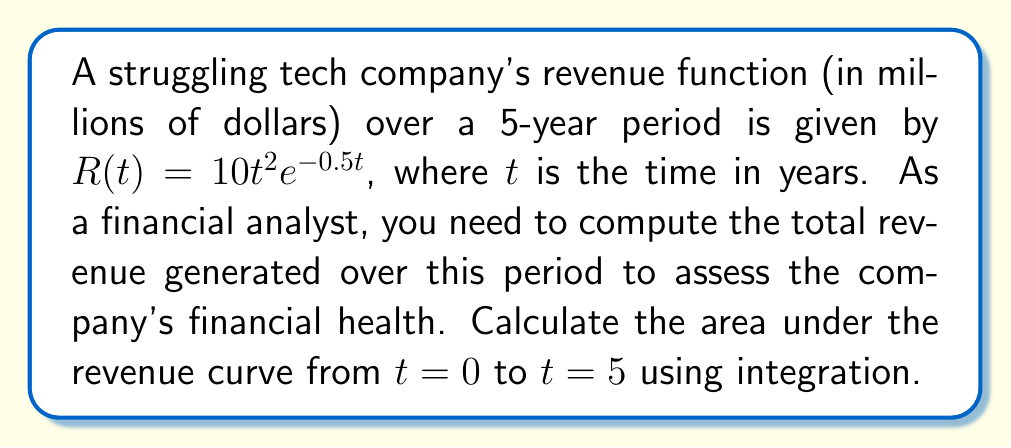Teach me how to tackle this problem. To solve this problem, we need to integrate the revenue function $R(t)$ from $t=0$ to $t=5$. Let's break it down step-by-step:

1) The revenue function is $R(t) = 10t^2e^{-0.5t}$

2) We need to calculate $\int_0^5 R(t) dt$

3) Set up the integral:
   $$\int_0^5 10t^2e^{-0.5t} dt$$

4) This integral cannot be solved using basic integration techniques. We need to use integration by parts twice.

5) Let $u = t^2$ and $dv = e^{-0.5t}dt$
   Then $du = 2t dt$ and $v = -2e^{-0.5t}$

6) Apply integration by parts: $\int u dv = uv - \int v du$
   $$\int_0^5 10t^2e^{-0.5t} dt = -20t^2e^{-0.5t}\bigg|_0^5 + \int_0^5 40te^{-0.5t} dt$$

7) For the remaining integral, let $u = t$ and $dv = e^{-0.5t}dt$
   Then $du = dt$ and $v = -2e^{-0.5t}$

8) Apply integration by parts again:
   $$-20t^2e^{-0.5t}\bigg|_0^5 - 80te^{-0.5t}\bigg|_0^5 + \int_0^5 80e^{-0.5t} dt$$

9) Evaluate the last integral:
   $$-20t^2e^{-0.5t}\bigg|_0^5 - 80te^{-0.5t}\bigg|_0^5 - 160e^{-0.5t}\bigg|_0^5$$

10) Evaluate the expression at the limits:
    $$(-20(5^2)e^{-0.5(5)} - 0) + (-80(5)e^{-0.5(5)} - 0) + (-160e^{-0.5(5)} + 160)$$

11) Simplify:
    $$-500e^{-2.5} - 400e^{-2.5} - 160e^{-2.5} + 160$$
    $$= -1060e^{-2.5} + 160$$
    $$\approx 160 - 28.77 = 131.23$$

Therefore, the total revenue over the 5-year period is approximately 131.23 million dollars.
Answer: $131.23 million 